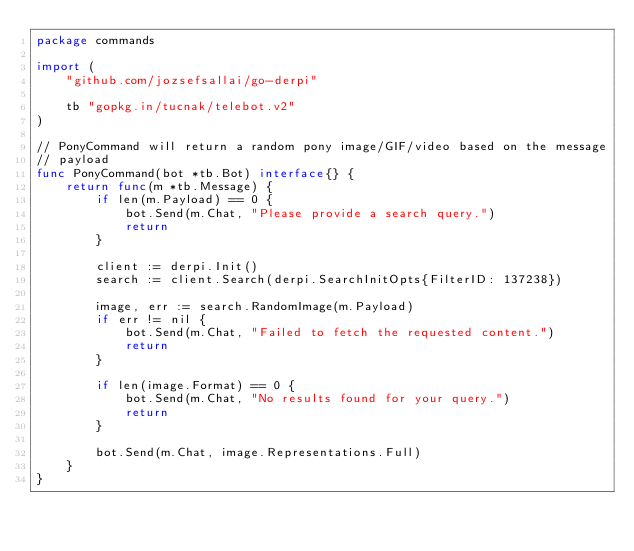Convert code to text. <code><loc_0><loc_0><loc_500><loc_500><_Go_>package commands

import (
	"github.com/jozsefsallai/go-derpi"

	tb "gopkg.in/tucnak/telebot.v2"
)

// PonyCommand will return a random pony image/GIF/video based on the message
// payload
func PonyCommand(bot *tb.Bot) interface{} {
	return func(m *tb.Message) {
		if len(m.Payload) == 0 {
			bot.Send(m.Chat, "Please provide a search query.")
			return
		}

		client := derpi.Init()
		search := client.Search(derpi.SearchInitOpts{FilterID: 137238})

		image, err := search.RandomImage(m.Payload)
		if err != nil {
			bot.Send(m.Chat, "Failed to fetch the requested content.")
			return
		}

		if len(image.Format) == 0 {
			bot.Send(m.Chat, "No results found for your query.")
			return
		}

		bot.Send(m.Chat, image.Representations.Full)
	}
}
</code> 